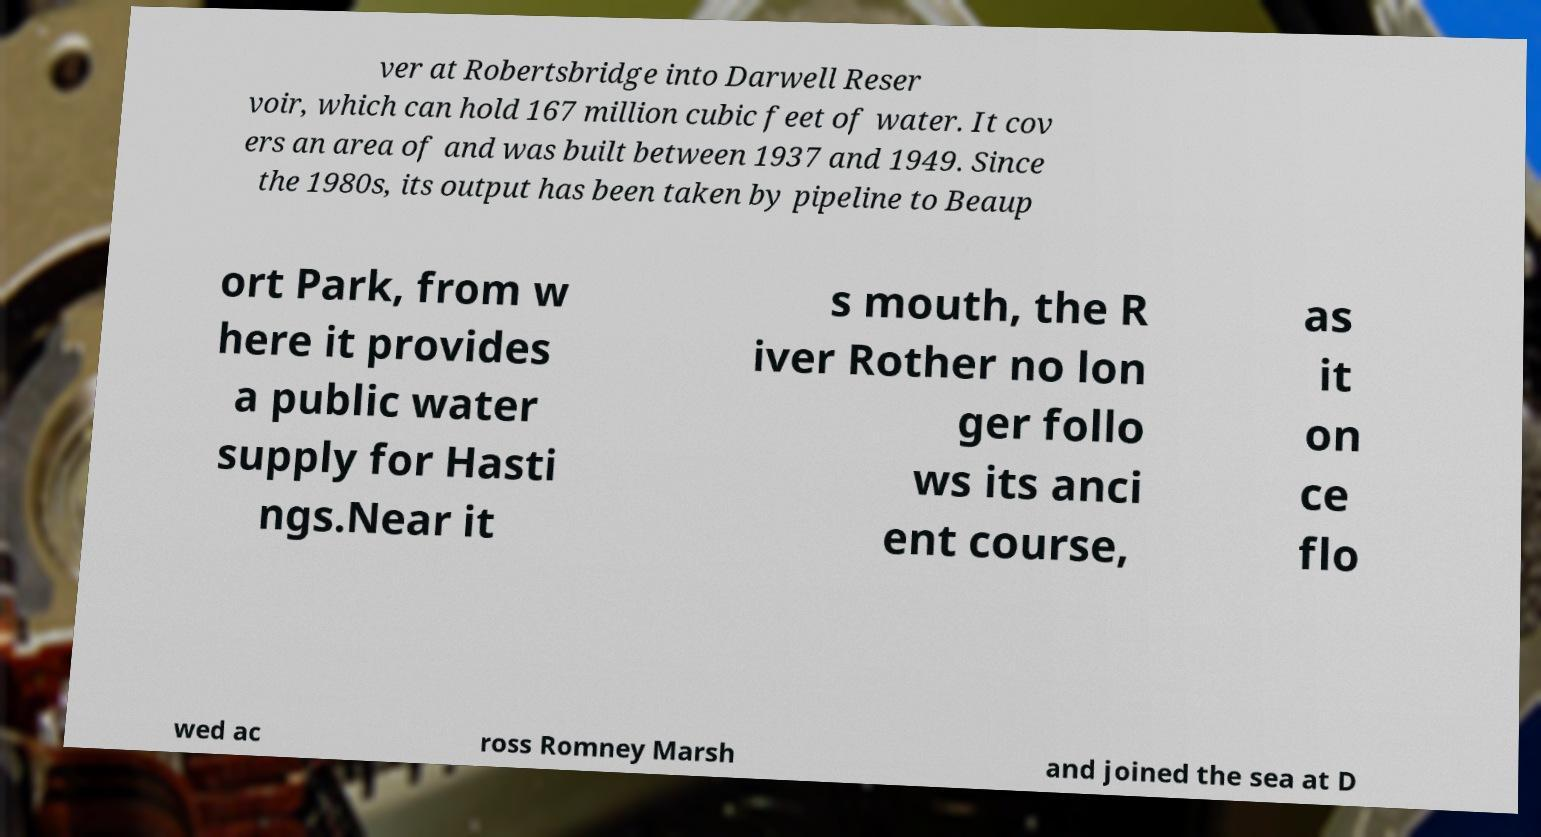Can you read and provide the text displayed in the image?This photo seems to have some interesting text. Can you extract and type it out for me? ver at Robertsbridge into Darwell Reser voir, which can hold 167 million cubic feet of water. It cov ers an area of and was built between 1937 and 1949. Since the 1980s, its output has been taken by pipeline to Beaup ort Park, from w here it provides a public water supply for Hasti ngs.Near it s mouth, the R iver Rother no lon ger follo ws its anci ent course, as it on ce flo wed ac ross Romney Marsh and joined the sea at D 